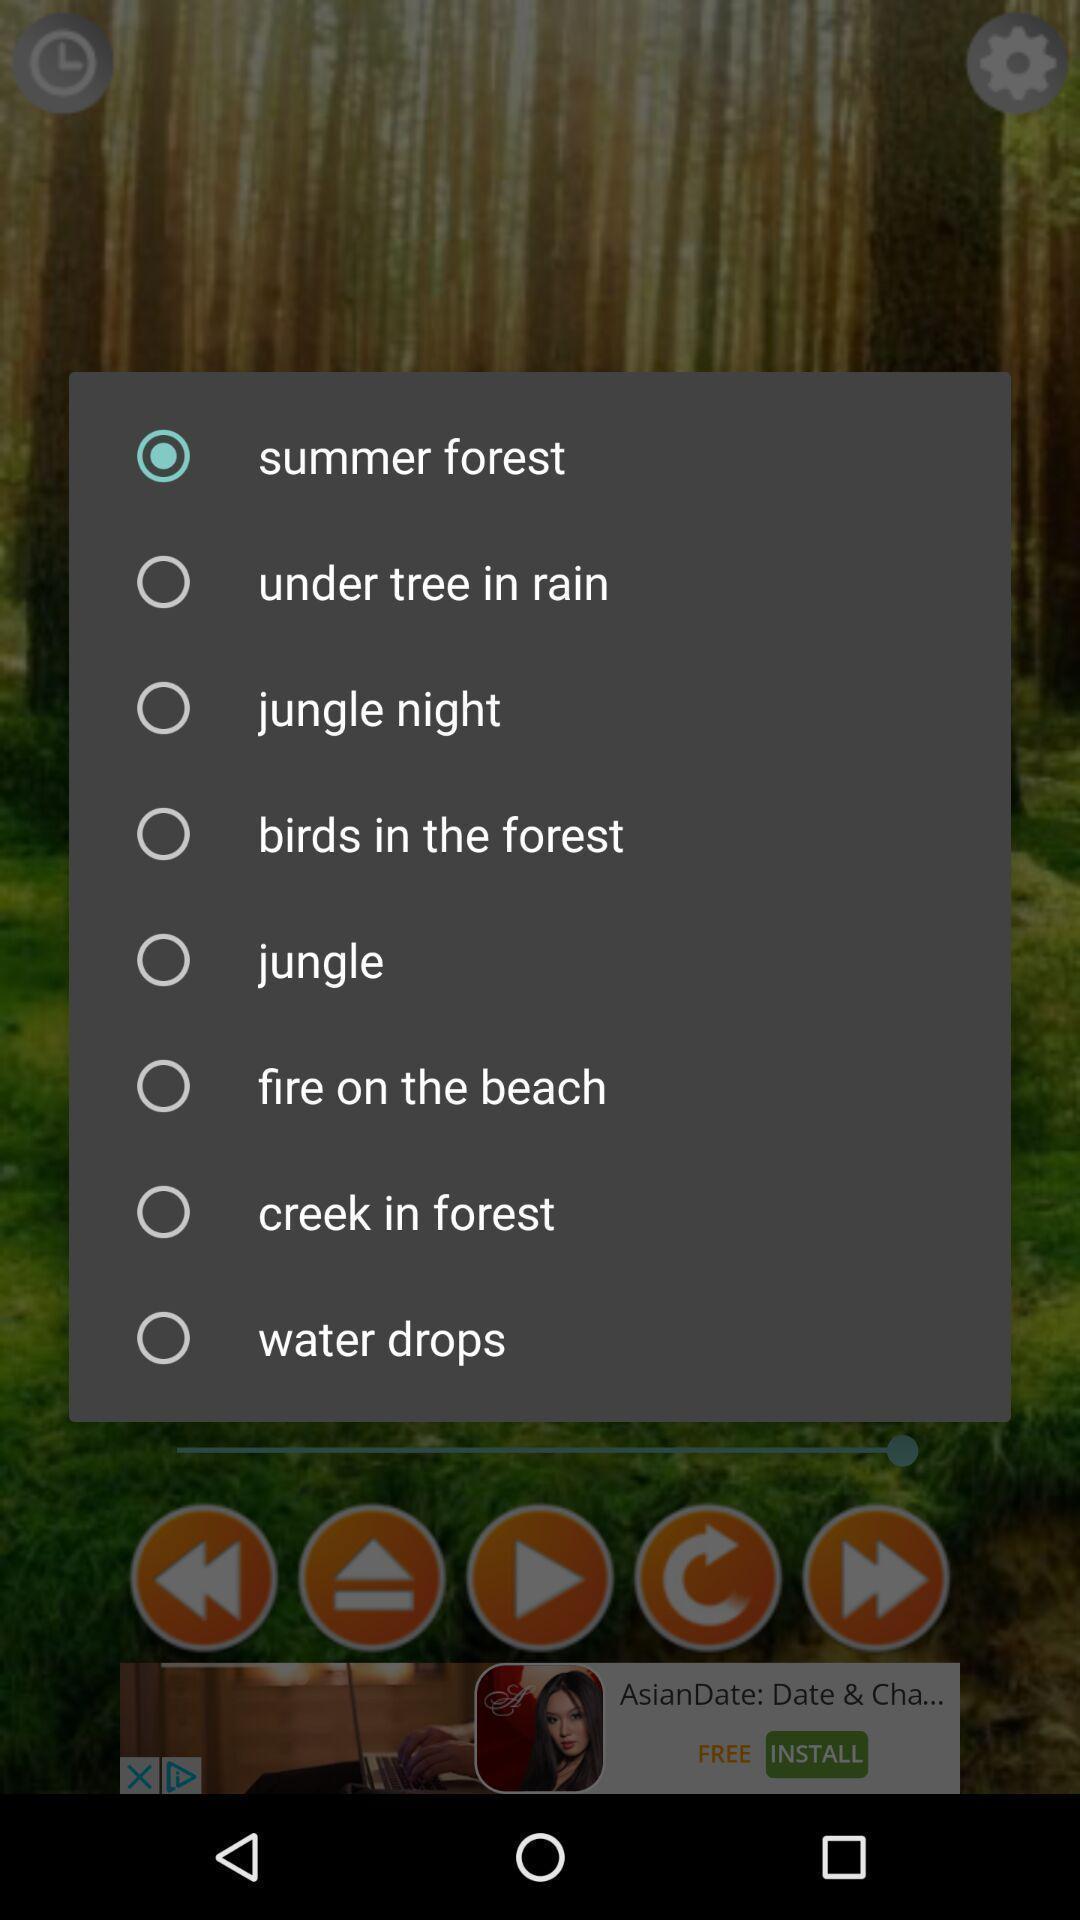Describe the visual elements of this screenshot. Pop-up with options like jungle and summer forest to select. 